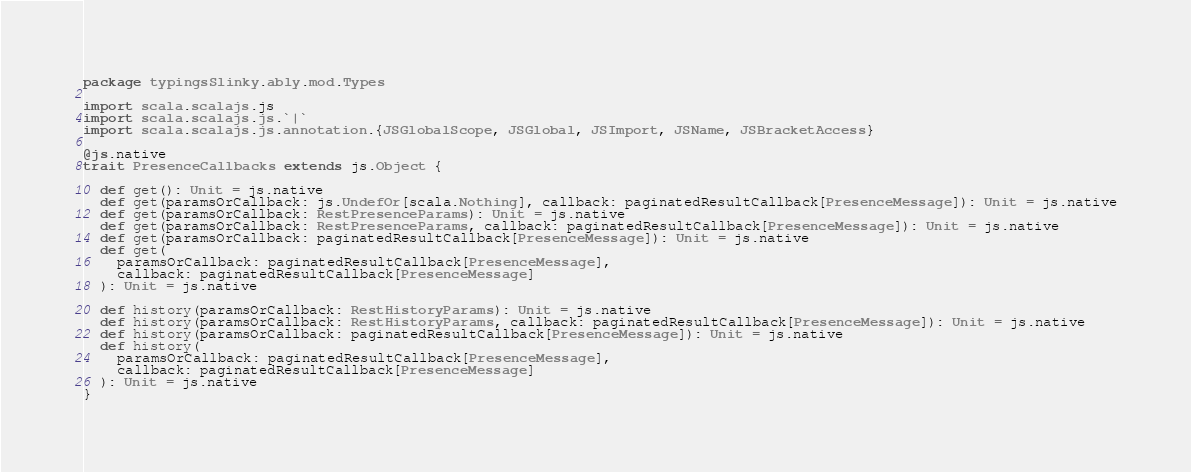<code> <loc_0><loc_0><loc_500><loc_500><_Scala_>package typingsSlinky.ably.mod.Types

import scala.scalajs.js
import scala.scalajs.js.`|`
import scala.scalajs.js.annotation.{JSGlobalScope, JSGlobal, JSImport, JSName, JSBracketAccess}

@js.native
trait PresenceCallbacks extends js.Object {
  
  def get(): Unit = js.native
  def get(paramsOrCallback: js.UndefOr[scala.Nothing], callback: paginatedResultCallback[PresenceMessage]): Unit = js.native
  def get(paramsOrCallback: RestPresenceParams): Unit = js.native
  def get(paramsOrCallback: RestPresenceParams, callback: paginatedResultCallback[PresenceMessage]): Unit = js.native
  def get(paramsOrCallback: paginatedResultCallback[PresenceMessage]): Unit = js.native
  def get(
    paramsOrCallback: paginatedResultCallback[PresenceMessage],
    callback: paginatedResultCallback[PresenceMessage]
  ): Unit = js.native
  
  def history(paramsOrCallback: RestHistoryParams): Unit = js.native
  def history(paramsOrCallback: RestHistoryParams, callback: paginatedResultCallback[PresenceMessage]): Unit = js.native
  def history(paramsOrCallback: paginatedResultCallback[PresenceMessage]): Unit = js.native
  def history(
    paramsOrCallback: paginatedResultCallback[PresenceMessage],
    callback: paginatedResultCallback[PresenceMessage]
  ): Unit = js.native
}
</code> 